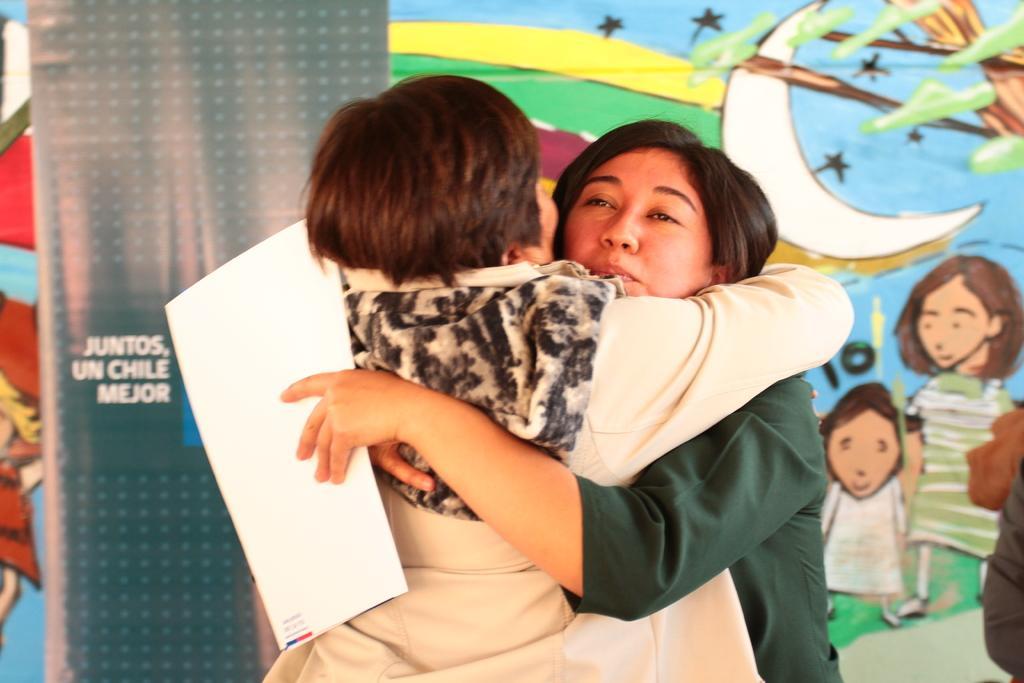In one or two sentences, can you explain what this image depicts? There are two persons here hugging each other and on the right side woman is holding paper in her hands. In the background there is a banner. 